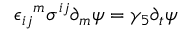Convert formula to latex. <formula><loc_0><loc_0><loc_500><loc_500>{ \epsilon _ { i j } } ^ { m } \sigma ^ { i j } \partial _ { m } \psi = \gamma _ { 5 } \partial _ { t } \psi</formula> 